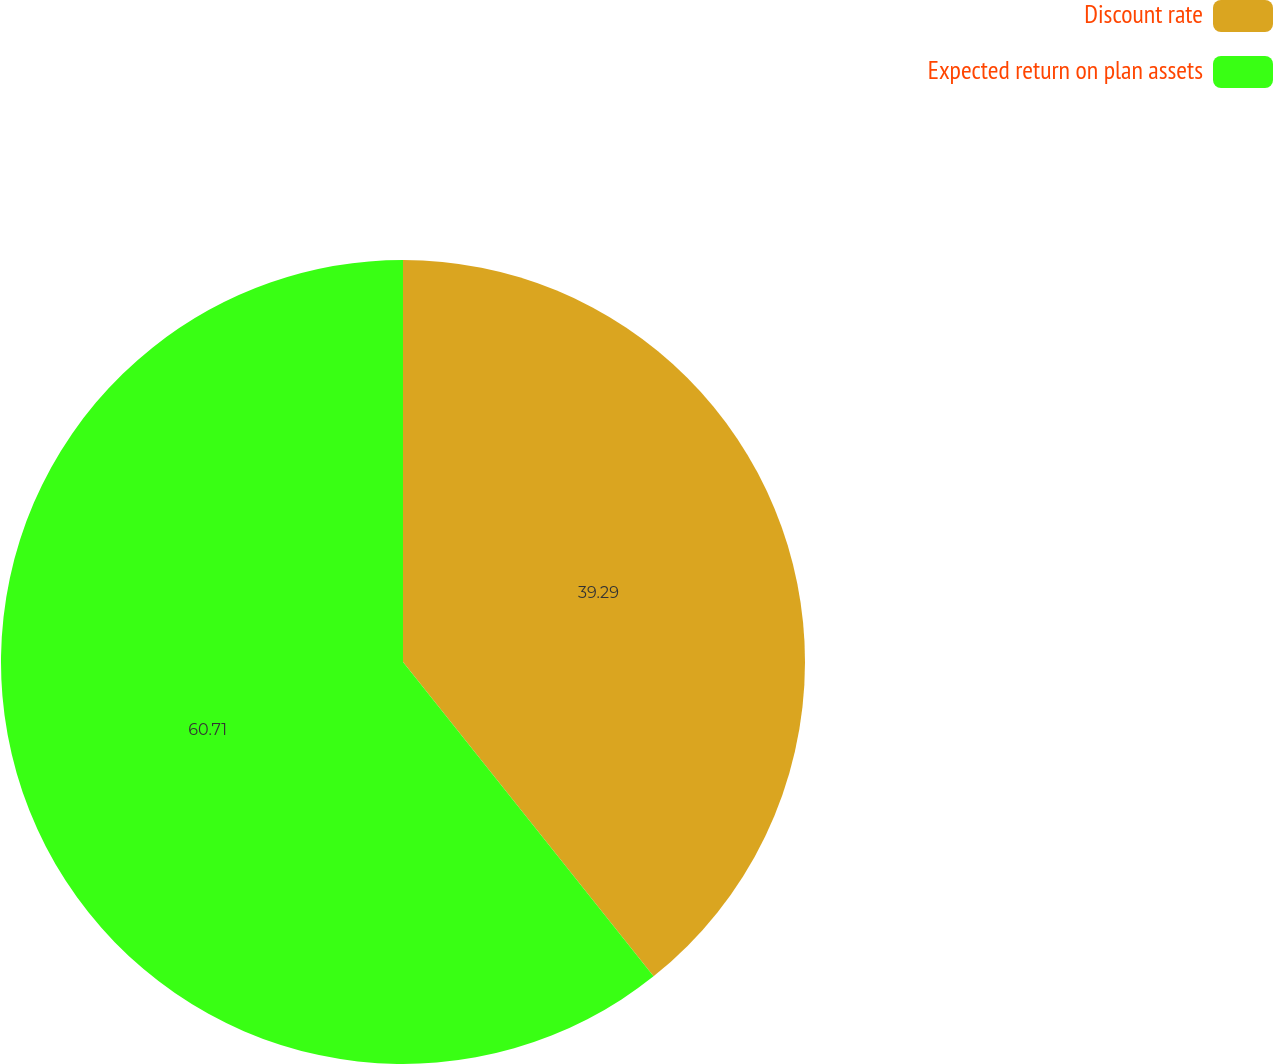Convert chart to OTSL. <chart><loc_0><loc_0><loc_500><loc_500><pie_chart><fcel>Discount rate<fcel>Expected return on plan assets<nl><fcel>39.29%<fcel>60.71%<nl></chart> 